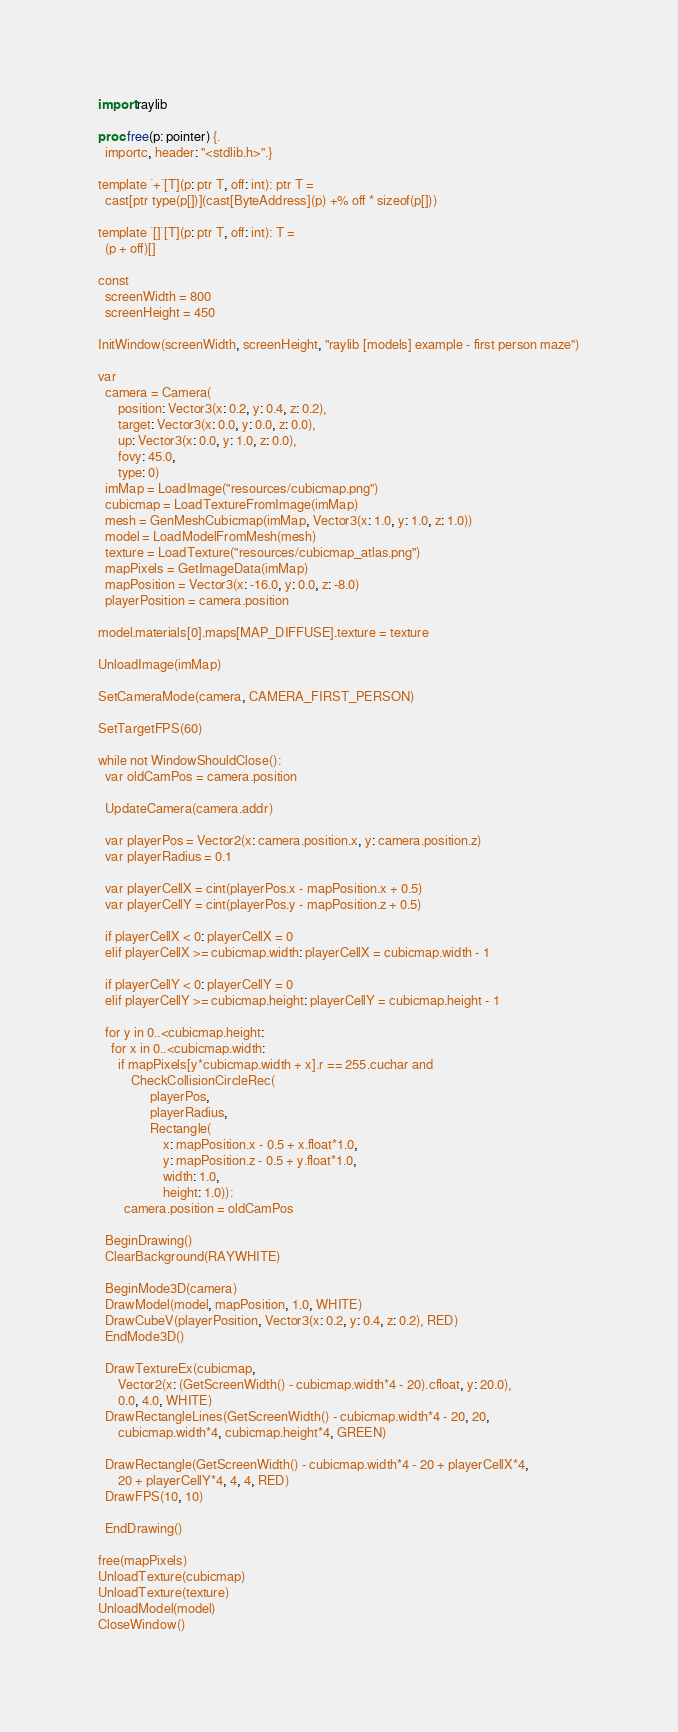Convert code to text. <code><loc_0><loc_0><loc_500><loc_500><_Nim_>import raylib

proc free(p: pointer) {.
  importc, header: "<stdlib.h>".}

template `+`[T](p: ptr T, off: int): ptr T =
  cast[ptr type(p[])](cast[ByteAddress](p) +% off * sizeof(p[]))

template `[]`[T](p: ptr T, off: int): T =
  (p + off)[]

const
  screenWidth = 800
  screenHeight = 450

InitWindow(screenWidth, screenHeight, "raylib [models] example - first person maze")

var
  camera = Camera(
      position: Vector3(x: 0.2, y: 0.4, z: 0.2),
      target: Vector3(x: 0.0, y: 0.0, z: 0.0),
      up: Vector3(x: 0.0, y: 1.0, z: 0.0),
      fovy: 45.0,
      type: 0)
  imMap = LoadImage("resources/cubicmap.png")
  cubicmap = LoadTextureFromImage(imMap)
  mesh = GenMeshCubicmap(imMap, Vector3(x: 1.0, y: 1.0, z: 1.0))
  model = LoadModelFromMesh(mesh)
  texture = LoadTexture("resources/cubicmap_atlas.png")
  mapPixels = GetImageData(imMap)
  mapPosition = Vector3(x: -16.0, y: 0.0, z: -8.0)
  playerPosition = camera.position

model.materials[0].maps[MAP_DIFFUSE].texture = texture

UnloadImage(imMap)

SetCameraMode(camera, CAMERA_FIRST_PERSON)

SetTargetFPS(60)

while not WindowShouldClose():
  var oldCamPos = camera.position

  UpdateCamera(camera.addr)

  var playerPos = Vector2(x: camera.position.x, y: camera.position.z)
  var playerRadius = 0.1

  var playerCellX = cint(playerPos.x - mapPosition.x + 0.5)
  var playerCellY = cint(playerPos.y - mapPosition.z + 0.5)

  if playerCellX < 0: playerCellX = 0
  elif playerCellX >= cubicmap.width: playerCellX = cubicmap.width - 1

  if playerCellY < 0: playerCellY = 0
  elif playerCellY >= cubicmap.height: playerCellY = cubicmap.height - 1

  for y in 0..<cubicmap.height:
    for x in 0..<cubicmap.width:
      if mapPixels[y*cubicmap.width + x].r == 255.cuchar and
          CheckCollisionCircleRec(
                playerPos,
                playerRadius,
                Rectangle(
                    x: mapPosition.x - 0.5 + x.float*1.0,
                    y: mapPosition.z - 0.5 + y.float*1.0,
                    width: 1.0,
                    height: 1.0)):
        camera.position = oldCamPos

  BeginDrawing()
  ClearBackground(RAYWHITE)

  BeginMode3D(camera)
  DrawModel(model, mapPosition, 1.0, WHITE)
  DrawCubeV(playerPosition, Vector3(x: 0.2, y: 0.4, z: 0.2), RED)
  EndMode3D()

  DrawTextureEx(cubicmap,
      Vector2(x: (GetScreenWidth() - cubicmap.width*4 - 20).cfloat, y: 20.0),
      0.0, 4.0, WHITE)
  DrawRectangleLines(GetScreenWidth() - cubicmap.width*4 - 20, 20,
      cubicmap.width*4, cubicmap.height*4, GREEN)

  DrawRectangle(GetScreenWidth() - cubicmap.width*4 - 20 + playerCellX*4,
      20 + playerCellY*4, 4, 4, RED)
  DrawFPS(10, 10)

  EndDrawing()

free(mapPixels)
UnloadTexture(cubicmap)
UnloadTexture(texture)
UnloadModel(model)
CloseWindow()
</code> 